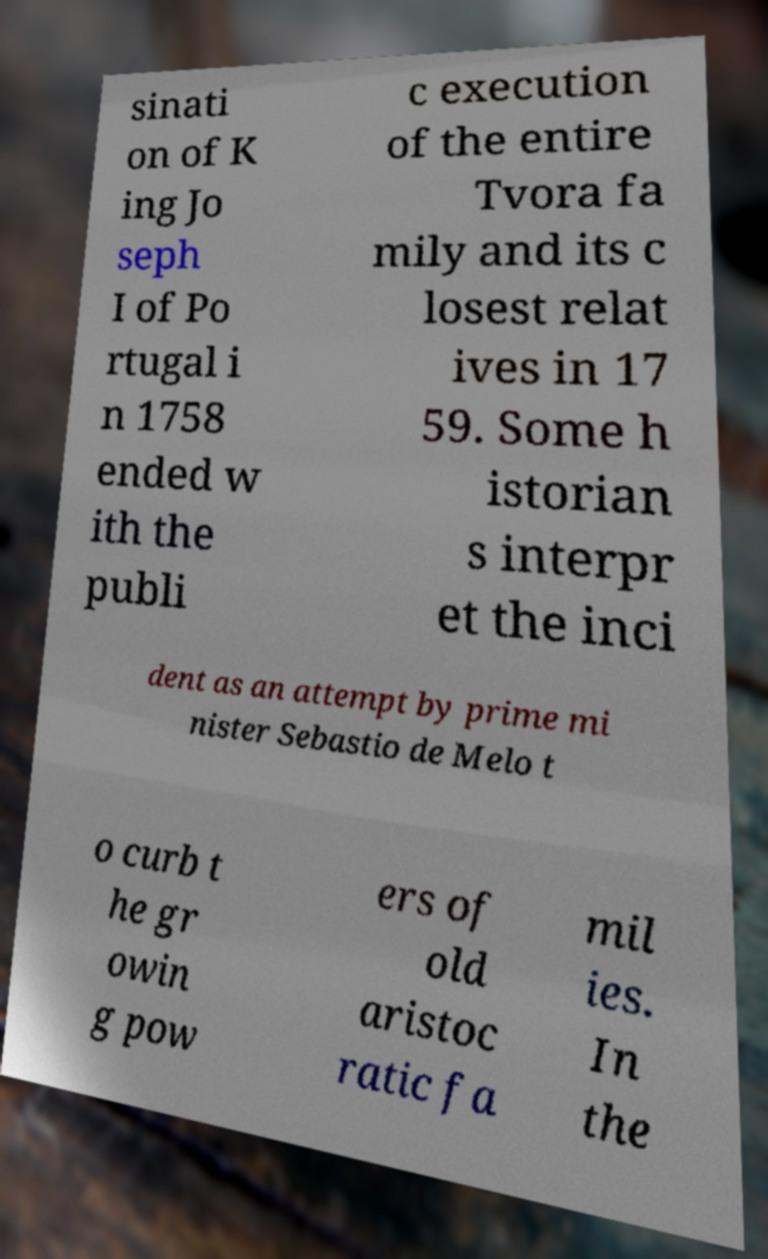There's text embedded in this image that I need extracted. Can you transcribe it verbatim? sinati on of K ing Jo seph I of Po rtugal i n 1758 ended w ith the publi c execution of the entire Tvora fa mily and its c losest relat ives in 17 59. Some h istorian s interpr et the inci dent as an attempt by prime mi nister Sebastio de Melo t o curb t he gr owin g pow ers of old aristoc ratic fa mil ies. In the 